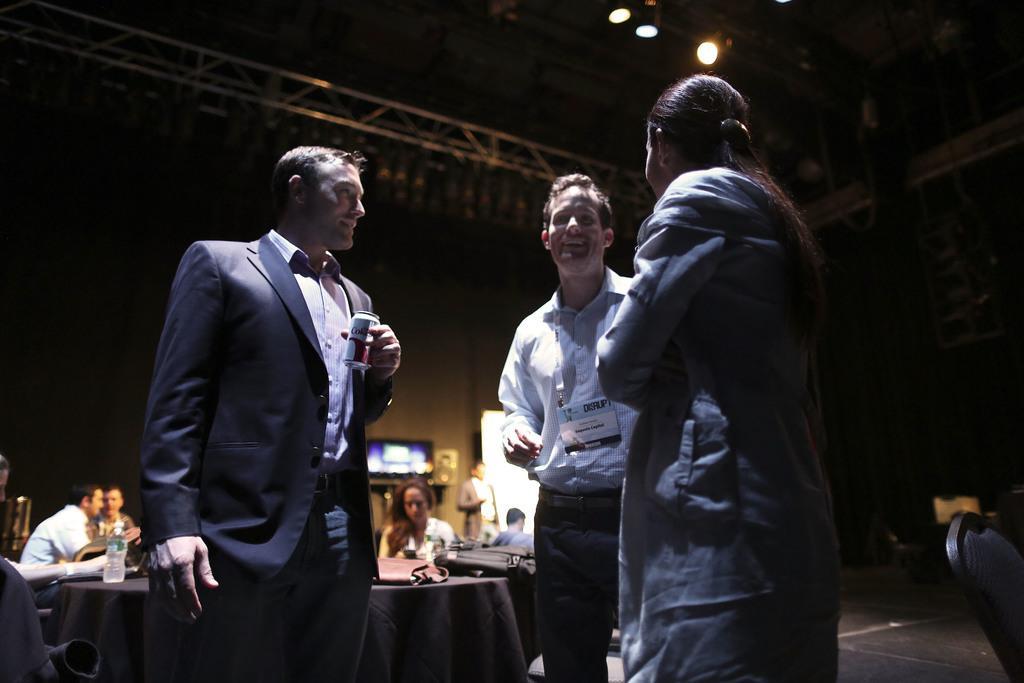Could you give a brief overview of what you see in this image? In this image we can see three people talking to each other. One man is holding a tin. On the backside we can see a roof, ceiling lights, wall, television, a person standing, a woman holding a cellphone, two people talking to each other. We can also see a bottle, bags on a table covered with a cloth. On the right side we can see a chair and the floor. 